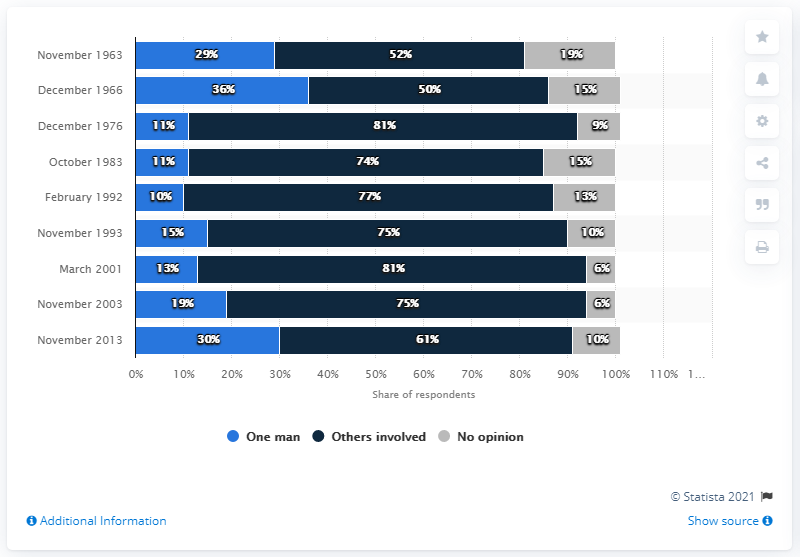Outline some significant characteristics in this image. According to the data, 30% of the respondents believed that the assassination was carried out by one man alone. 